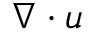<formula> <loc_0><loc_0><loc_500><loc_500>\nabla \cdot u</formula> 